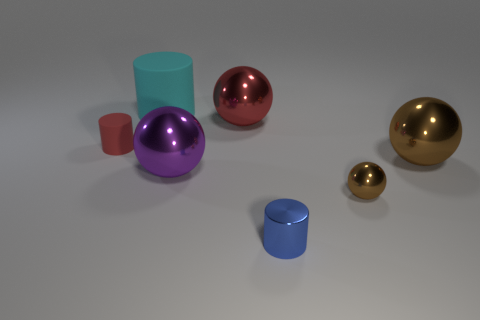There is a rubber thing that is left of the matte cylinder behind the small thing behind the large brown shiny thing; what is its shape?
Make the answer very short. Cylinder. What shape is the object that is on the right side of the tiny metallic cylinder and behind the small brown shiny ball?
Provide a short and direct response. Sphere. How many things are either metallic cylinders or spheres that are to the right of the small blue object?
Provide a succinct answer. 3. Is the material of the small sphere the same as the large cyan object?
Provide a succinct answer. No. How many other objects are there of the same shape as the cyan object?
Your answer should be very brief. 2. What size is the object that is both in front of the big purple metallic thing and behind the tiny blue cylinder?
Your answer should be very brief. Small. What number of rubber things are tiny blue blocks or purple spheres?
Ensure brevity in your answer.  0. Does the brown metal object in front of the large purple metallic ball have the same shape as the tiny thing that is to the left of the large purple metal ball?
Make the answer very short. No. Is there a tiny brown object that has the same material as the large purple sphere?
Your answer should be compact. Yes. What color is the big matte thing?
Provide a short and direct response. Cyan. 